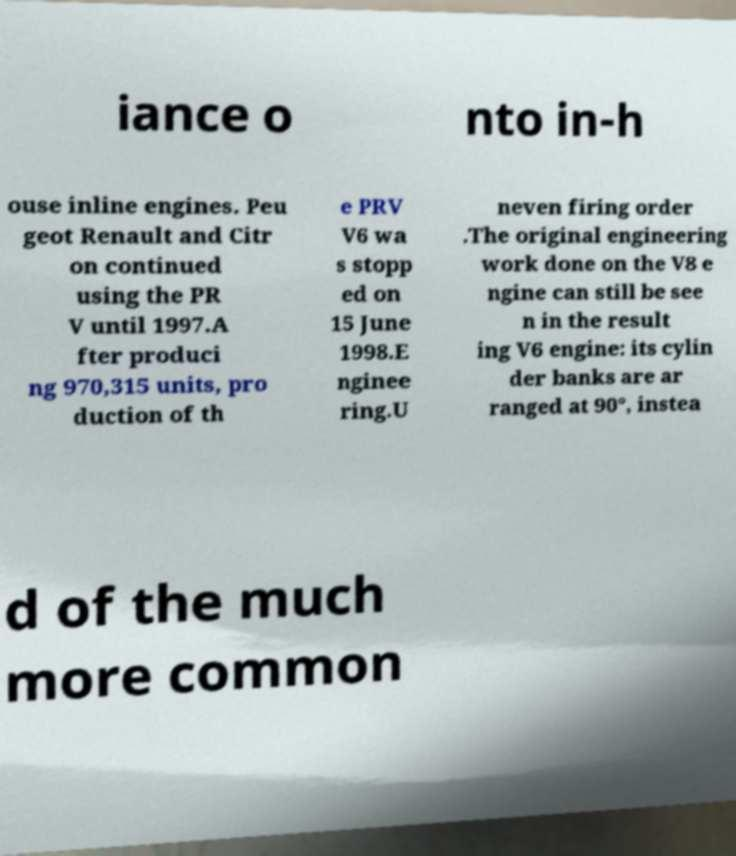For documentation purposes, I need the text within this image transcribed. Could you provide that? iance o nto in-h ouse inline engines. Peu geot Renault and Citr on continued using the PR V until 1997.A fter produci ng 970,315 units, pro duction of th e PRV V6 wa s stopp ed on 15 June 1998.E nginee ring.U neven firing order .The original engineering work done on the V8 e ngine can still be see n in the result ing V6 engine: its cylin der banks are ar ranged at 90°, instea d of the much more common 